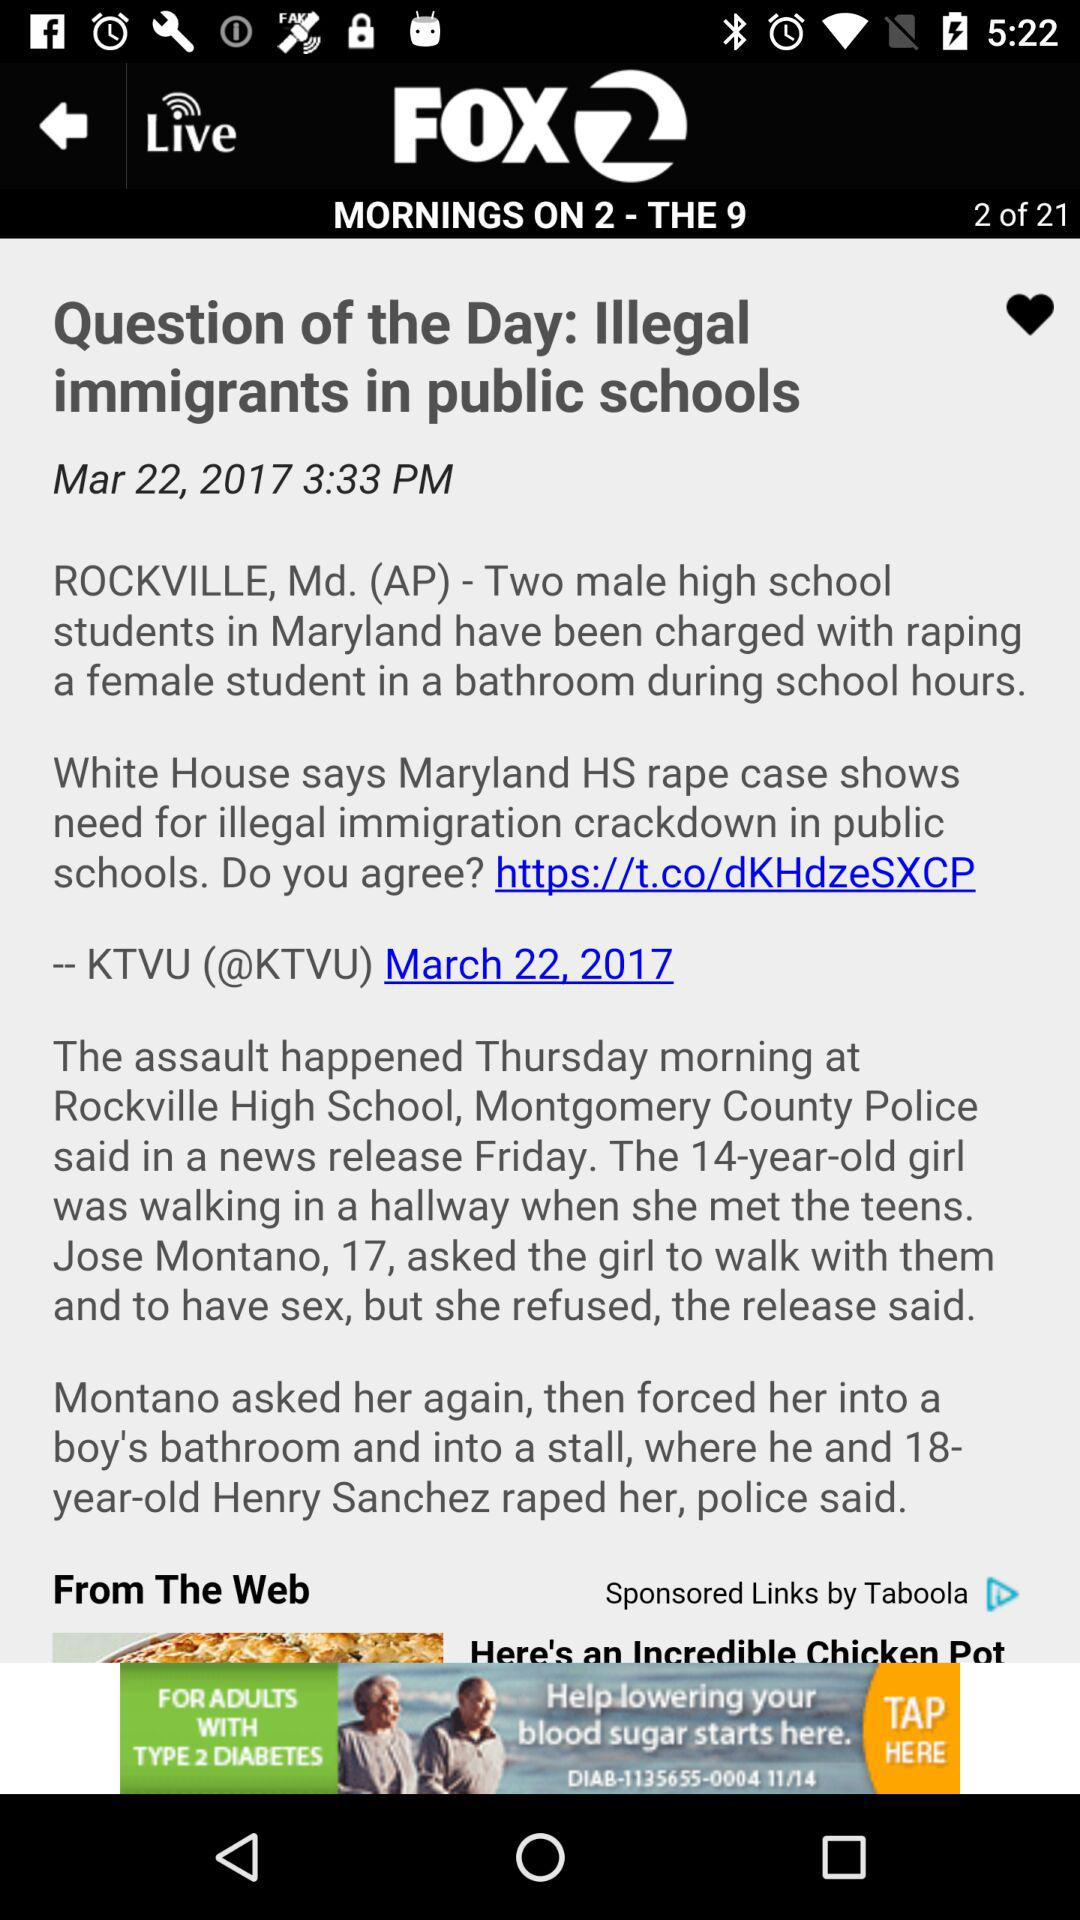What is the application name? The application name is "KTVU FOX 2 San Francisco: News". 